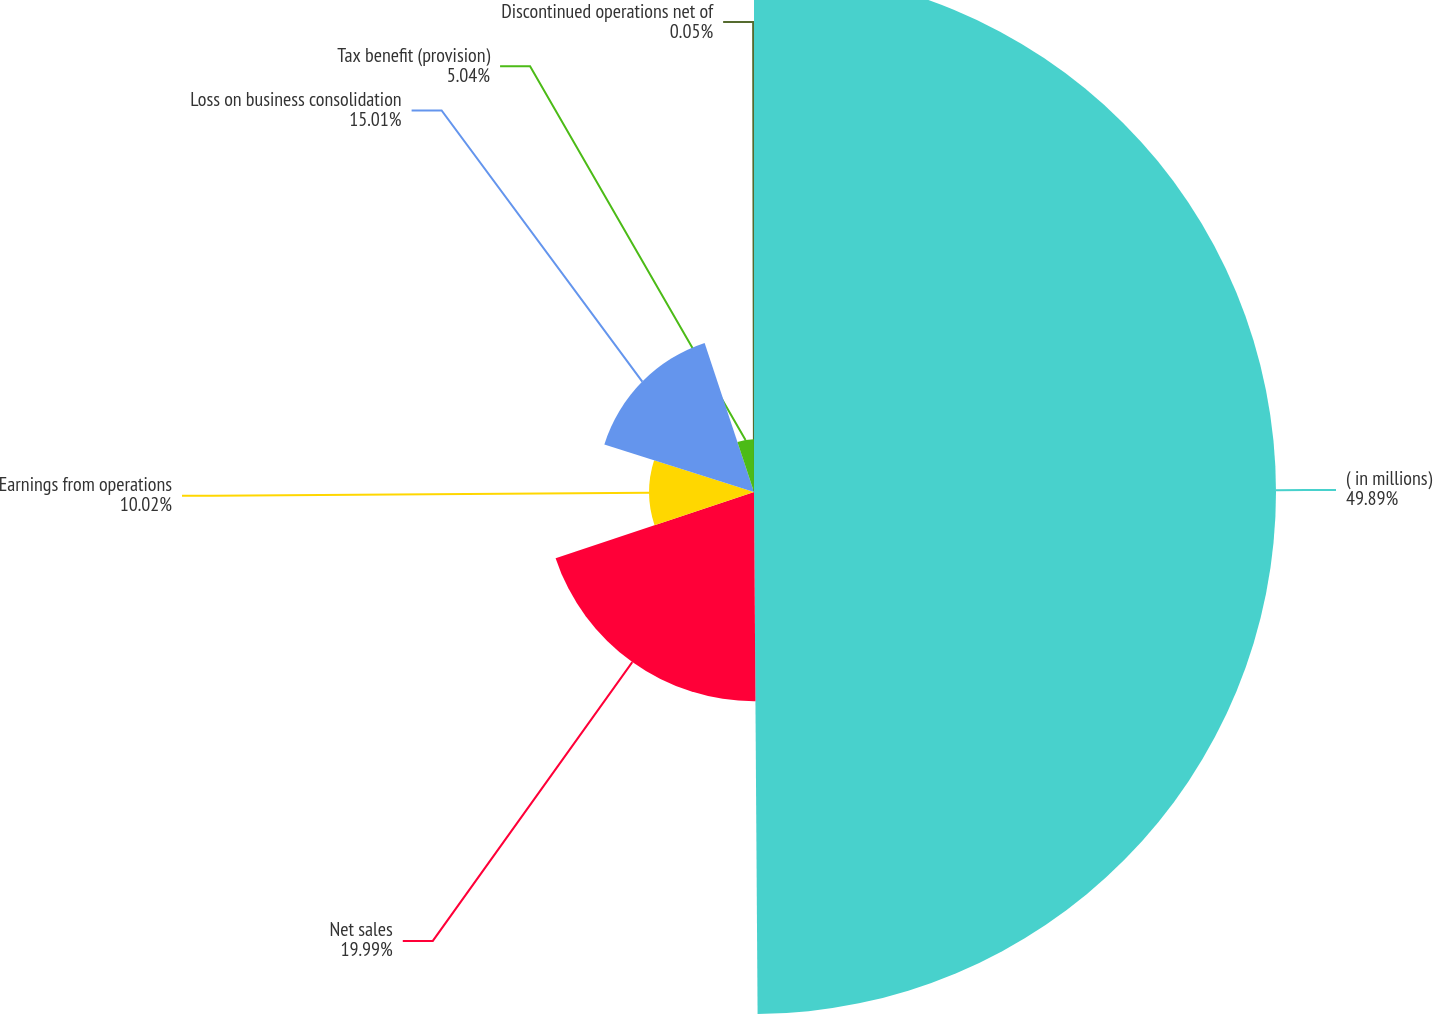Convert chart. <chart><loc_0><loc_0><loc_500><loc_500><pie_chart><fcel>( in millions)<fcel>Net sales<fcel>Earnings from operations<fcel>Loss on business consolidation<fcel>Tax benefit (provision)<fcel>Discontinued operations net of<nl><fcel>49.89%<fcel>19.99%<fcel>10.02%<fcel>15.01%<fcel>5.04%<fcel>0.05%<nl></chart> 